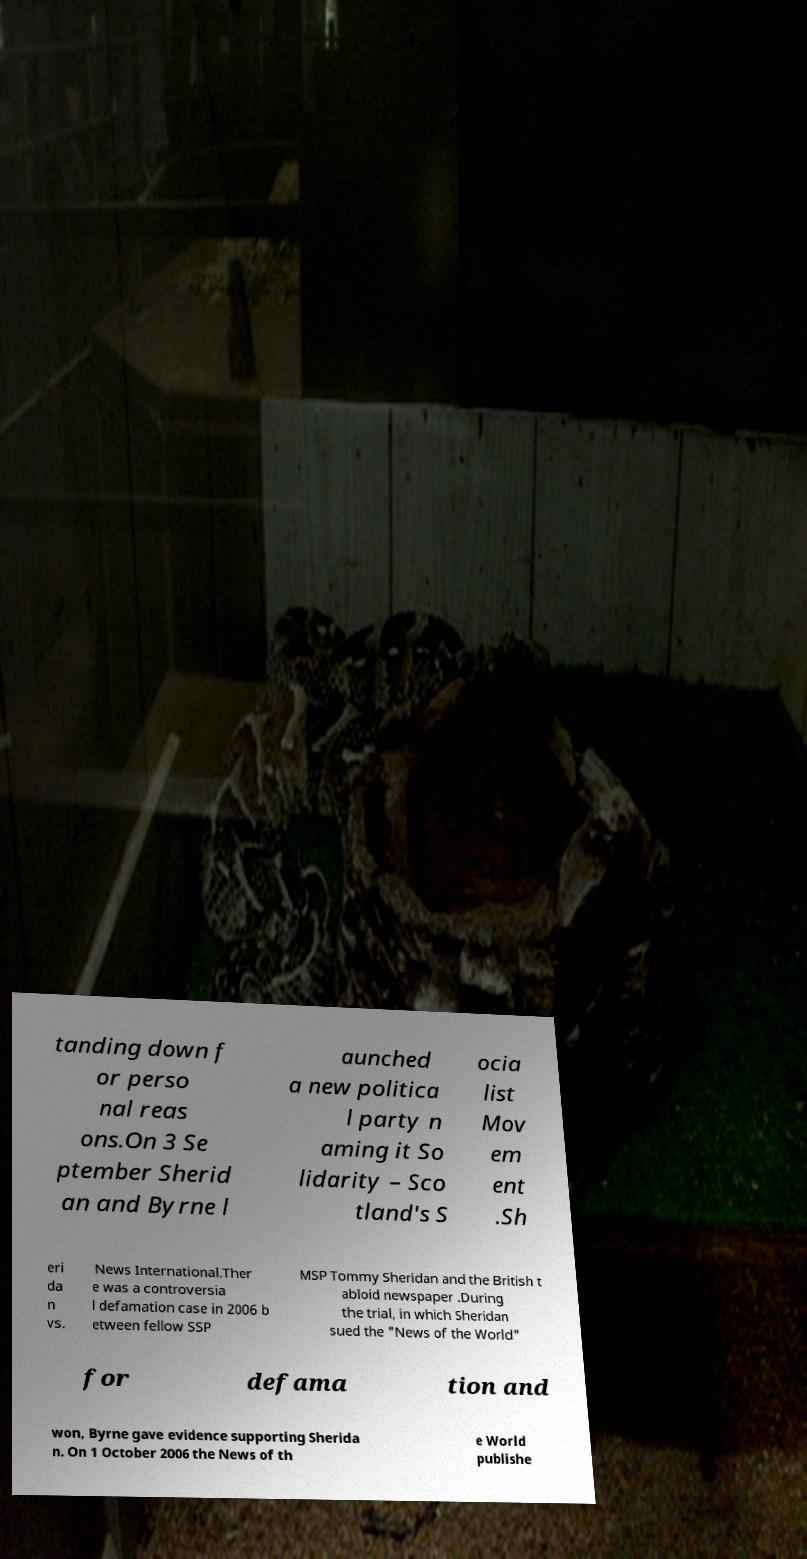What messages or text are displayed in this image? I need them in a readable, typed format. tanding down f or perso nal reas ons.On 3 Se ptember Sherid an and Byrne l aunched a new politica l party n aming it So lidarity – Sco tland's S ocia list Mov em ent .Sh eri da n vs. News International.Ther e was a controversia l defamation case in 2006 b etween fellow SSP MSP Tommy Sheridan and the British t abloid newspaper .During the trial, in which Sheridan sued the "News of the World" for defama tion and won, Byrne gave evidence supporting Sherida n. On 1 October 2006 the News of th e World publishe 